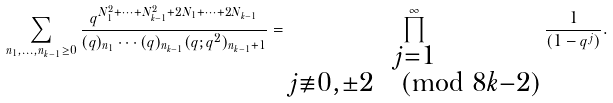Convert formula to latex. <formula><loc_0><loc_0><loc_500><loc_500>\sum _ { n _ { 1 } , \dots , n _ { k - 1 } \geq 0 } \frac { q ^ { N _ { 1 } ^ { 2 } + \cdots + N _ { k - 1 } ^ { 2 } + 2 N _ { 1 } + \cdots + 2 N _ { k - 1 } } } { ( q ) _ { n _ { 1 } } \cdots ( q ) _ { n _ { k - 1 } } ( q ; q ^ { 2 } ) _ { n _ { k - 1 } + 1 } } = \prod _ { \substack { j = 1 \\ j \not \equiv 0 , \pm 2 \pmod { 8 k - 2 } } } ^ { \infty } \frac { 1 } { ( 1 - q ^ { j } ) } .</formula> 